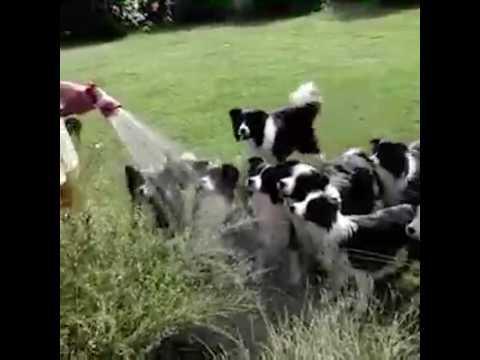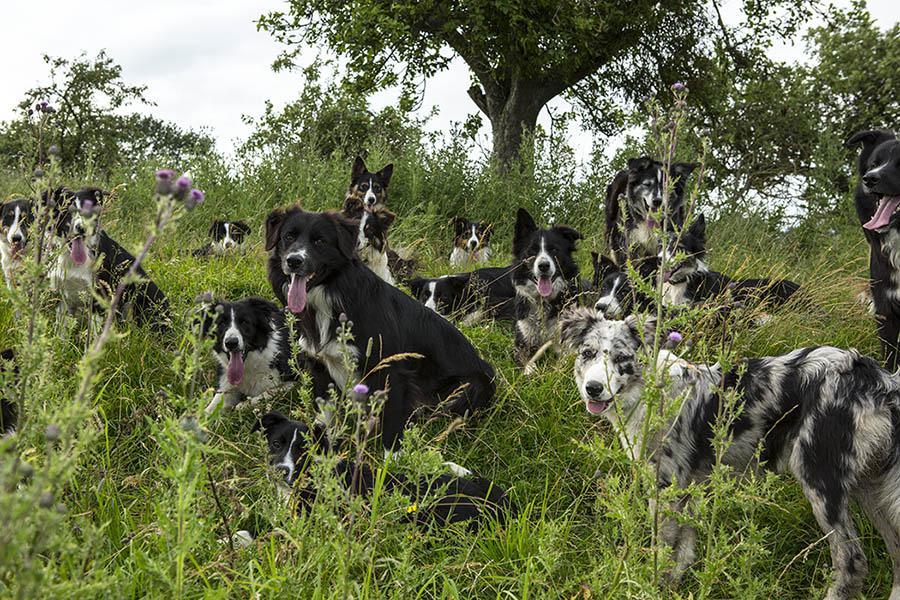The first image is the image on the left, the second image is the image on the right. For the images shown, is this caption "An image shows a nozzle spraying water at a group of black-and-white dogs." true? Answer yes or no. Yes. The first image is the image on the left, the second image is the image on the right. For the images displayed, is the sentence "There are at least half a dozen dogs lying in a line on the grass in one of the images." factually correct? Answer yes or no. No. 